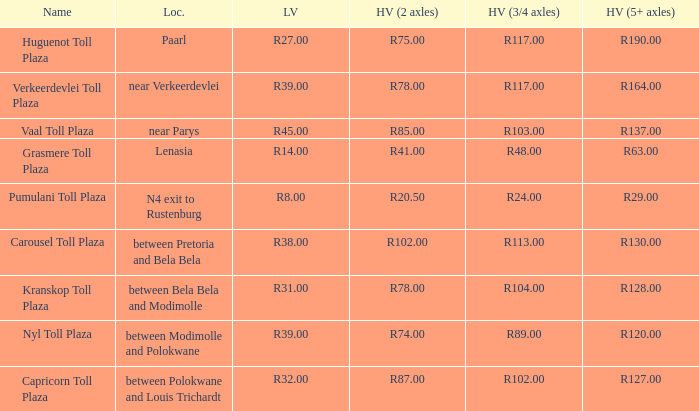Could you parse the entire table as a dict? {'header': ['Name', 'Loc.', 'LV', 'HV (2 axles)', 'HV (3/4 axles)', 'HV (5+ axles)'], 'rows': [['Huguenot Toll Plaza', 'Paarl', 'R27.00', 'R75.00', 'R117.00', 'R190.00'], ['Verkeerdevlei Toll Plaza', 'near Verkeerdevlei', 'R39.00', 'R78.00', 'R117.00', 'R164.00'], ['Vaal Toll Plaza', 'near Parys', 'R45.00', 'R85.00', 'R103.00', 'R137.00'], ['Grasmere Toll Plaza', 'Lenasia', 'R14.00', 'R41.00', 'R48.00', 'R63.00'], ['Pumulani Toll Plaza', 'N4 exit to Rustenburg', 'R8.00', 'R20.50', 'R24.00', 'R29.00'], ['Carousel Toll Plaza', 'between Pretoria and Bela Bela', 'R38.00', 'R102.00', 'R113.00', 'R130.00'], ['Kranskop Toll Plaza', 'between Bela Bela and Modimolle', 'R31.00', 'R78.00', 'R104.00', 'R128.00'], ['Nyl Toll Plaza', 'between Modimolle and Polokwane', 'R39.00', 'R74.00', 'R89.00', 'R120.00'], ['Capricorn Toll Plaza', 'between Polokwane and Louis Trichardt', 'R32.00', 'R87.00', 'R102.00', 'R127.00']]} What is the toll for light vehicles at the plaza where the toll for heavy vehicles with 2 axles is r87.00? R32.00. 